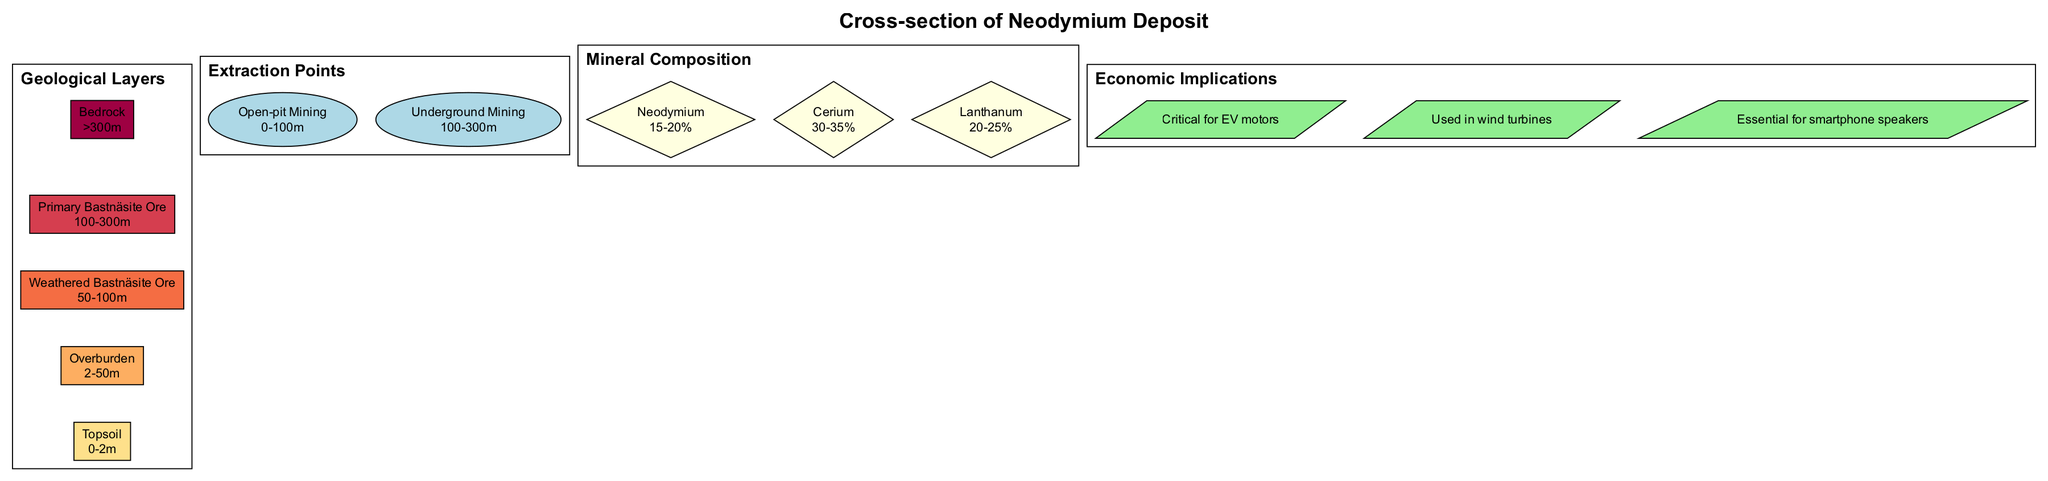What is the depth range of the Topsoil layer? The depth range of the Topsoil layer is specified in the diagram as from 0 to 2 meters. Thus, to find the answer, I reviewed the information provided for the layers and extracted the depth range for the Topsoil.
Answer: 0-2m What is the name of the extraction method for depths up to 100 meters? The extraction method for depths up to 100 meters is listed in the diagram under extraction points, which directly states "Open-pit Mining" for this depth range.
Answer: Open-pit Mining How many minerals are listed in the mineral composition? The mineral composition section of the diagram indicates three distinct minerals: Neodymium, Cerium, and Lanthanum. By counting these entries, I determined the total number of minerals.
Answer: 3 What percentage of Neodymium is present in the mineral composition? The mineral composition specifies that Neodymium comprises 15 to 20 percent. By extracting the relevant information directly from that node in the diagram, I arrived at this figure.
Answer: 15-20% What layer do you find the Primary Bastnäsite Ore? To answer this question, I referred to the geological layers section, where the Primary Bastnäsite Ore is explicitly mentioned and situated at the depth of 100 to 300 meters.
Answer: Primary Bastnäsite Ore Which extraction method is used for depths greater than 100 meters? According to the extraction points in the diagram, the method employed for depths greater than 100 meters is "Underground Mining." This is identified directly from the extraction points listed.
Answer: Underground Mining What is the depth of the Weathered Bastnäsite Ore layer? The Weathered Bastnäsite Ore layer is described in the diagram with the depth range of 50 to 100 meters, as listed under the geological layers. I found this value by locating the specific layer in the diagram.
Answer: 50-100m Which economic implication is related to wind turbines? From the economic implications listed in the diagram, I found that the statement "Used in wind turbines" corresponds directly to the economic usage of the mineral, confirming its relation to wind turbines.
Answer: Used in wind turbines How many geological layers are represented in the diagram? By counting the entries in the geological layers section of the diagram, which lists the layers from Topsoil to Bedrock, I identified that there are five layers in total.
Answer: 5 